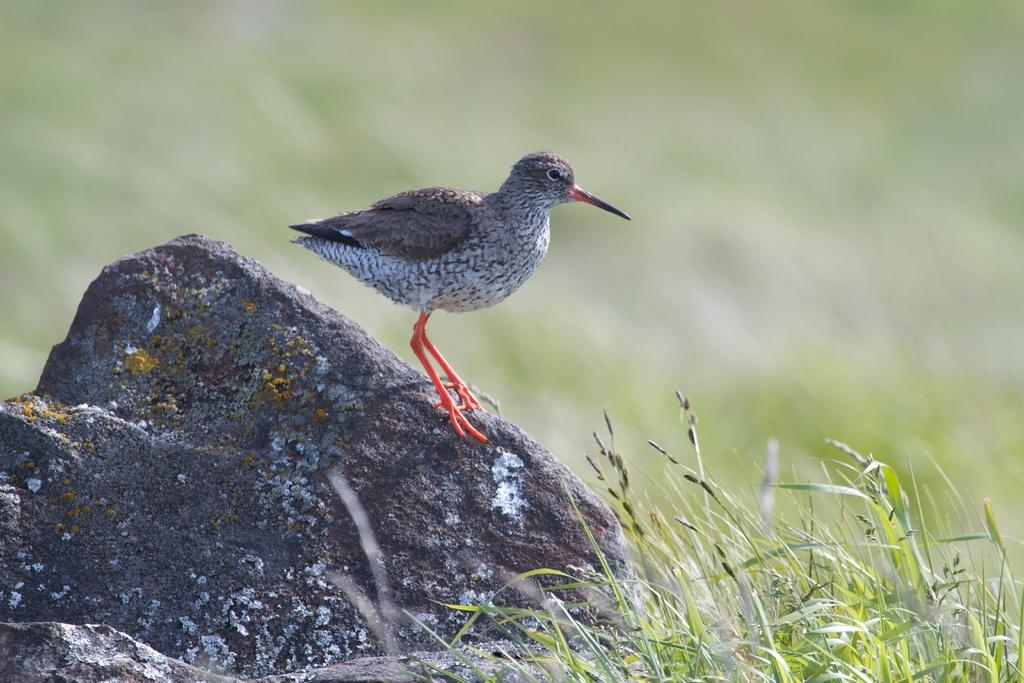What is the main object in the image? There is a stone in the image. What type of vegetation is near the stone? Grass plants are near the stone. What animal can be seen on the stone? A bird is standing on the stone. Where is the drawer located in the image? There is no drawer present in the image. What type of drink is being served in the image? The image does not show any drinks, including eggnog. 